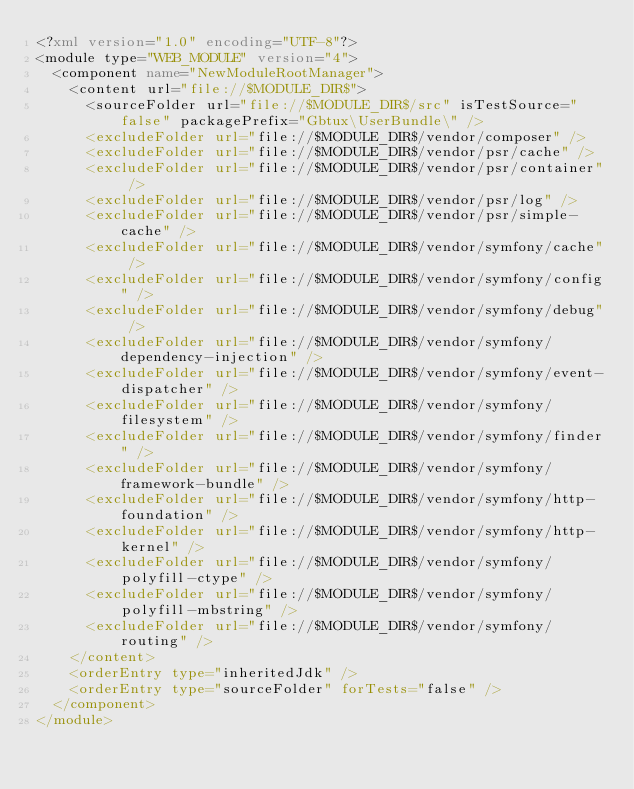Convert code to text. <code><loc_0><loc_0><loc_500><loc_500><_XML_><?xml version="1.0" encoding="UTF-8"?>
<module type="WEB_MODULE" version="4">
  <component name="NewModuleRootManager">
    <content url="file://$MODULE_DIR$">
      <sourceFolder url="file://$MODULE_DIR$/src" isTestSource="false" packagePrefix="Gbtux\UserBundle\" />
      <excludeFolder url="file://$MODULE_DIR$/vendor/composer" />
      <excludeFolder url="file://$MODULE_DIR$/vendor/psr/cache" />
      <excludeFolder url="file://$MODULE_DIR$/vendor/psr/container" />
      <excludeFolder url="file://$MODULE_DIR$/vendor/psr/log" />
      <excludeFolder url="file://$MODULE_DIR$/vendor/psr/simple-cache" />
      <excludeFolder url="file://$MODULE_DIR$/vendor/symfony/cache" />
      <excludeFolder url="file://$MODULE_DIR$/vendor/symfony/config" />
      <excludeFolder url="file://$MODULE_DIR$/vendor/symfony/debug" />
      <excludeFolder url="file://$MODULE_DIR$/vendor/symfony/dependency-injection" />
      <excludeFolder url="file://$MODULE_DIR$/vendor/symfony/event-dispatcher" />
      <excludeFolder url="file://$MODULE_DIR$/vendor/symfony/filesystem" />
      <excludeFolder url="file://$MODULE_DIR$/vendor/symfony/finder" />
      <excludeFolder url="file://$MODULE_DIR$/vendor/symfony/framework-bundle" />
      <excludeFolder url="file://$MODULE_DIR$/vendor/symfony/http-foundation" />
      <excludeFolder url="file://$MODULE_DIR$/vendor/symfony/http-kernel" />
      <excludeFolder url="file://$MODULE_DIR$/vendor/symfony/polyfill-ctype" />
      <excludeFolder url="file://$MODULE_DIR$/vendor/symfony/polyfill-mbstring" />
      <excludeFolder url="file://$MODULE_DIR$/vendor/symfony/routing" />
    </content>
    <orderEntry type="inheritedJdk" />
    <orderEntry type="sourceFolder" forTests="false" />
  </component>
</module></code> 